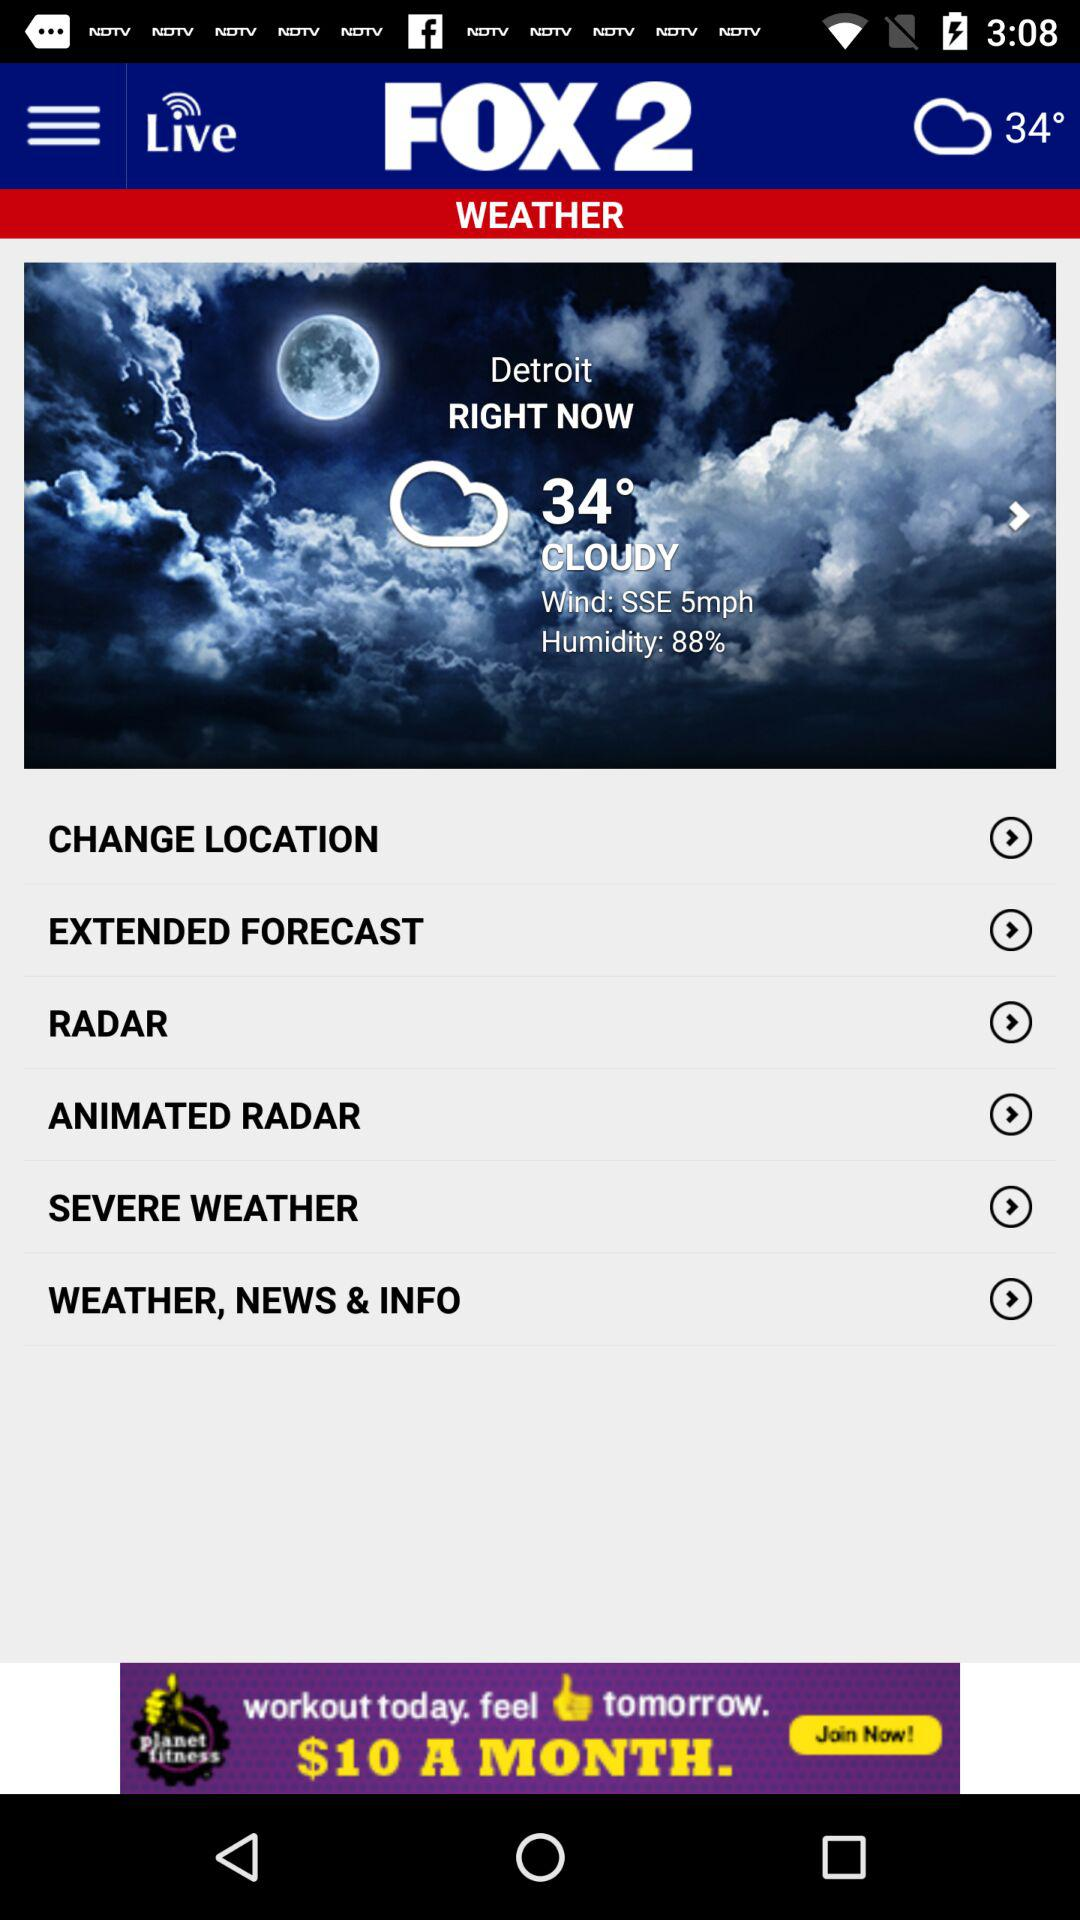What time was this weather report accessed? Based on the image of the weather report, it appears that the information was accessed at 3:08, as indicated by the time on the screen. 